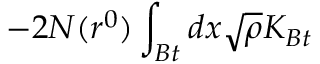<formula> <loc_0><loc_0><loc_500><loc_500>- 2 N ( r ^ { 0 } ) \int _ { B t } d x \sqrt { \rho } K _ { B t }</formula> 